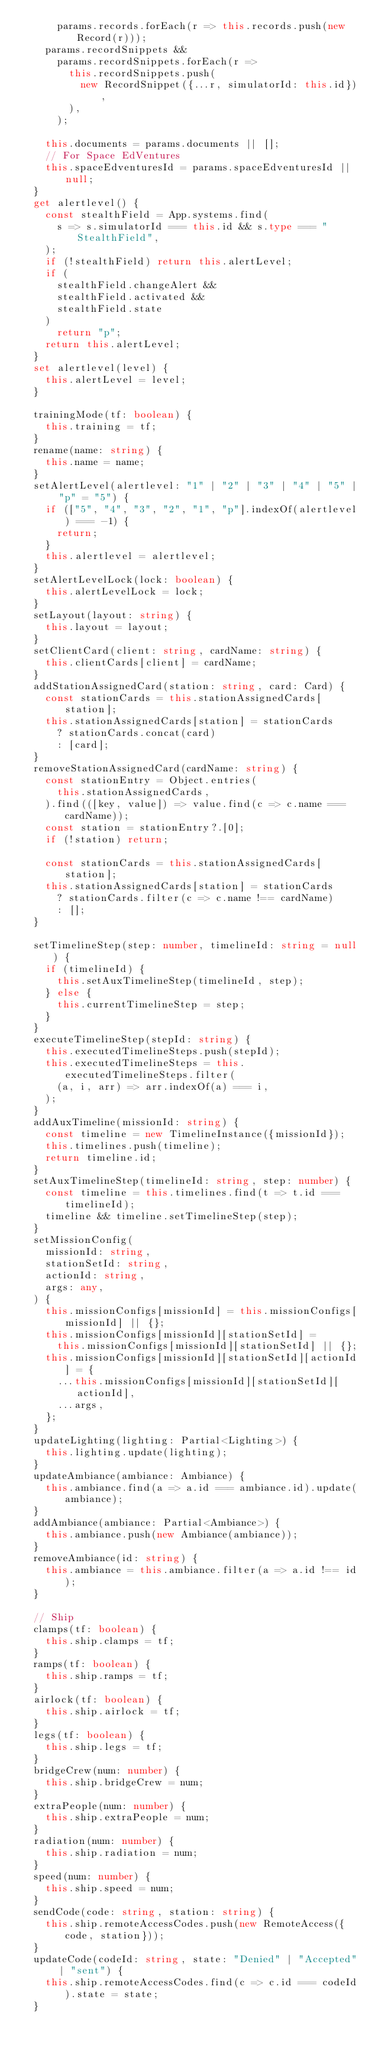<code> <loc_0><loc_0><loc_500><loc_500><_TypeScript_>      params.records.forEach(r => this.records.push(new Record(r)));
    params.recordSnippets &&
      params.recordSnippets.forEach(r =>
        this.recordSnippets.push(
          new RecordSnippet({...r, simulatorId: this.id}),
        ),
      );

    this.documents = params.documents || [];
    // For Space EdVentures
    this.spaceEdventuresId = params.spaceEdventuresId || null;
  }
  get alertlevel() {
    const stealthField = App.systems.find(
      s => s.simulatorId === this.id && s.type === "StealthField",
    );
    if (!stealthField) return this.alertLevel;
    if (
      stealthField.changeAlert &&
      stealthField.activated &&
      stealthField.state
    )
      return "p";
    return this.alertLevel;
  }
  set alertlevel(level) {
    this.alertLevel = level;
  }

  trainingMode(tf: boolean) {
    this.training = tf;
  }
  rename(name: string) {
    this.name = name;
  }
  setAlertLevel(alertlevel: "1" | "2" | "3" | "4" | "5" | "p" = "5") {
    if (["5", "4", "3", "2", "1", "p"].indexOf(alertlevel) === -1) {
      return;
    }
    this.alertlevel = alertlevel;
  }
  setAlertLevelLock(lock: boolean) {
    this.alertLevelLock = lock;
  }
  setLayout(layout: string) {
    this.layout = layout;
  }
  setClientCard(client: string, cardName: string) {
    this.clientCards[client] = cardName;
  }
  addStationAssignedCard(station: string, card: Card) {
    const stationCards = this.stationAssignedCards[station];
    this.stationAssignedCards[station] = stationCards
      ? stationCards.concat(card)
      : [card];
  }
  removeStationAssignedCard(cardName: string) {
    const stationEntry = Object.entries(
      this.stationAssignedCards,
    ).find(([key, value]) => value.find(c => c.name === cardName));
    const station = stationEntry?.[0];
    if (!station) return;

    const stationCards = this.stationAssignedCards[station];
    this.stationAssignedCards[station] = stationCards
      ? stationCards.filter(c => c.name !== cardName)
      : [];
  }

  setTimelineStep(step: number, timelineId: string = null) {
    if (timelineId) {
      this.setAuxTimelineStep(timelineId, step);
    } else {
      this.currentTimelineStep = step;
    }
  }
  executeTimelineStep(stepId: string) {
    this.executedTimelineSteps.push(stepId);
    this.executedTimelineSteps = this.executedTimelineSteps.filter(
      (a, i, arr) => arr.indexOf(a) === i,
    );
  }
  addAuxTimeline(missionId: string) {
    const timeline = new TimelineInstance({missionId});
    this.timelines.push(timeline);
    return timeline.id;
  }
  setAuxTimelineStep(timelineId: string, step: number) {
    const timeline = this.timelines.find(t => t.id === timelineId);
    timeline && timeline.setTimelineStep(step);
  }
  setMissionConfig(
    missionId: string,
    stationSetId: string,
    actionId: string,
    args: any,
  ) {
    this.missionConfigs[missionId] = this.missionConfigs[missionId] || {};
    this.missionConfigs[missionId][stationSetId] =
      this.missionConfigs[missionId][stationSetId] || {};
    this.missionConfigs[missionId][stationSetId][actionId] = {
      ...this.missionConfigs[missionId][stationSetId][actionId],
      ...args,
    };
  }
  updateLighting(lighting: Partial<Lighting>) {
    this.lighting.update(lighting);
  }
  updateAmbiance(ambiance: Ambiance) {
    this.ambiance.find(a => a.id === ambiance.id).update(ambiance);
  }
  addAmbiance(ambiance: Partial<Ambiance>) {
    this.ambiance.push(new Ambiance(ambiance));
  }
  removeAmbiance(id: string) {
    this.ambiance = this.ambiance.filter(a => a.id !== id);
  }

  // Ship
  clamps(tf: boolean) {
    this.ship.clamps = tf;
  }
  ramps(tf: boolean) {
    this.ship.ramps = tf;
  }
  airlock(tf: boolean) {
    this.ship.airlock = tf;
  }
  legs(tf: boolean) {
    this.ship.legs = tf;
  }
  bridgeCrew(num: number) {
    this.ship.bridgeCrew = num;
  }
  extraPeople(num: number) {
    this.ship.extraPeople = num;
  }
  radiation(num: number) {
    this.ship.radiation = num;
  }
  speed(num: number) {
    this.ship.speed = num;
  }
  sendCode(code: string, station: string) {
    this.ship.remoteAccessCodes.push(new RemoteAccess({code, station}));
  }
  updateCode(codeId: string, state: "Denied" | "Accepted" | "sent") {
    this.ship.remoteAccessCodes.find(c => c.id === codeId).state = state;
  }</code> 